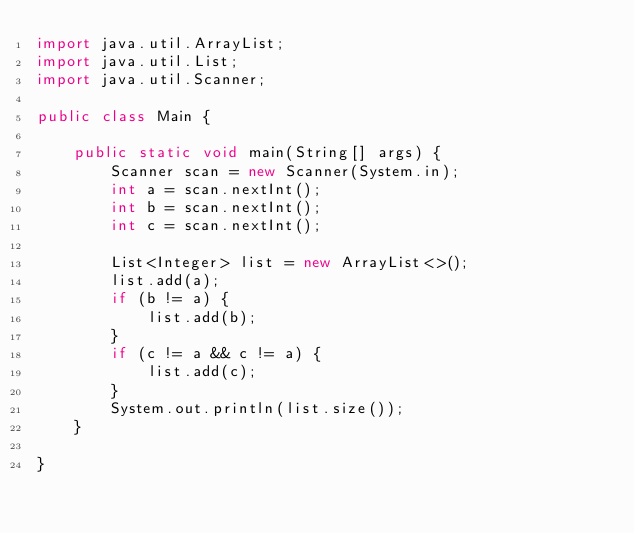<code> <loc_0><loc_0><loc_500><loc_500><_Java_>import java.util.ArrayList;
import java.util.List;
import java.util.Scanner;

public class Main {

	public static void main(String[] args) {
		Scanner scan = new Scanner(System.in);
		int a = scan.nextInt();
		int b = scan.nextInt();
		int c = scan.nextInt();
		
		List<Integer> list = new ArrayList<>();
		list.add(a);
		if (b != a) {
			list.add(b);
		}
		if (c != a && c != a) {
			list.add(c);
		}
		System.out.println(list.size());
	}

}</code> 